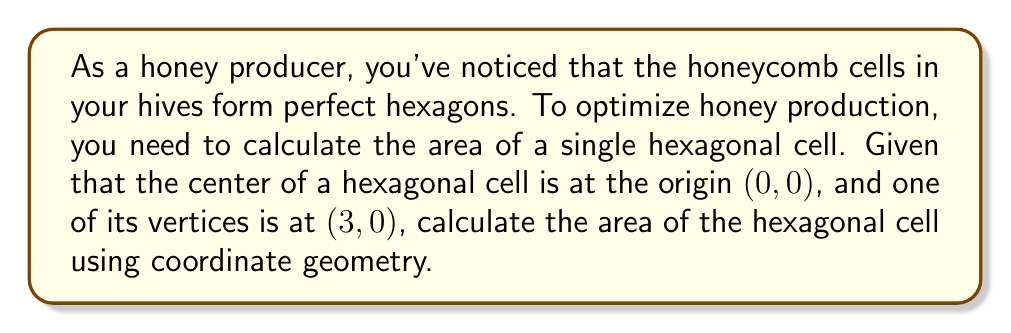Could you help me with this problem? Let's approach this step-by-step:

1) First, we need to identify the coordinates of all vertices of the hexagon. Given that one vertex is at (3, 0) and the center is at (0, 0), we can determine that the hexagon has a radius of 3 units.

2) The vertices of a regular hexagon centered at the origin form angles of 60° (π/3 radians) with each other. We can use this to find all vertices:

   $$(3, 0), (1.5, 2.598), (-1.5, 2.598), (-3, 0), (-1.5, -2.598), (1.5, -2.598)$$

3) To calculate the area, we can divide the hexagon into six equilateral triangles and calculate the area of one triangle, then multiply by 6.

4) The area of an equilateral triangle with side length $a$ is:

   $$A = \frac{\sqrt{3}}{4}a^2$$

5) The side length of our hexagon is equal to its radius, 3 units. So, the area of one triangle is:

   $$A = \frac{\sqrt{3}}{4}(3)^2 = \frac{9\sqrt{3}}{4}$$

6) The total area of the hexagon is 6 times this:

   $$A_{total} = 6 \cdot \frac{9\sqrt{3}}{4} = \frac{27\sqrt{3}}{2}$$

7) Simplifying:

   $$A_{total} = \frac{27\sqrt{3}}{2} \approx 23.3826 \text{ square units}$$
Answer: $\frac{27\sqrt{3}}{2}$ square units 